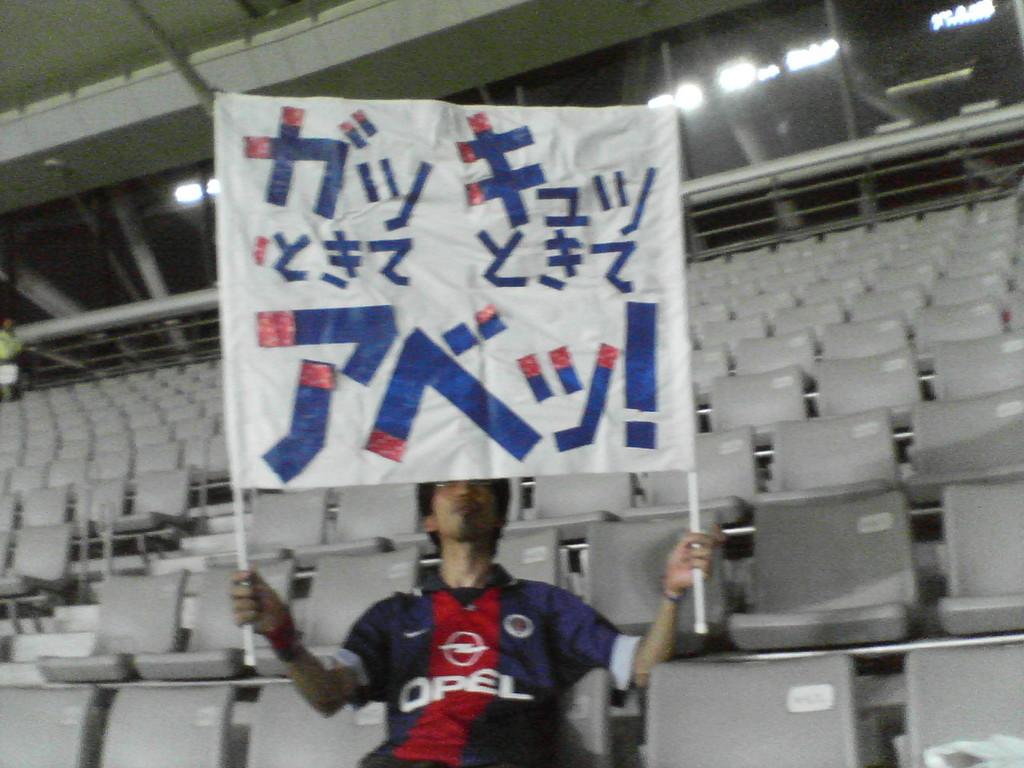What brand is mentioned on the jersey?
Offer a very short reply. Opel. 